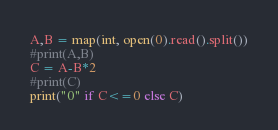<code> <loc_0><loc_0><loc_500><loc_500><_Python_>A,B = map(int, open(0).read().split())
#print(A,B)
C = A-B*2
#print(C)
print("0" if C<=0 else C)</code> 